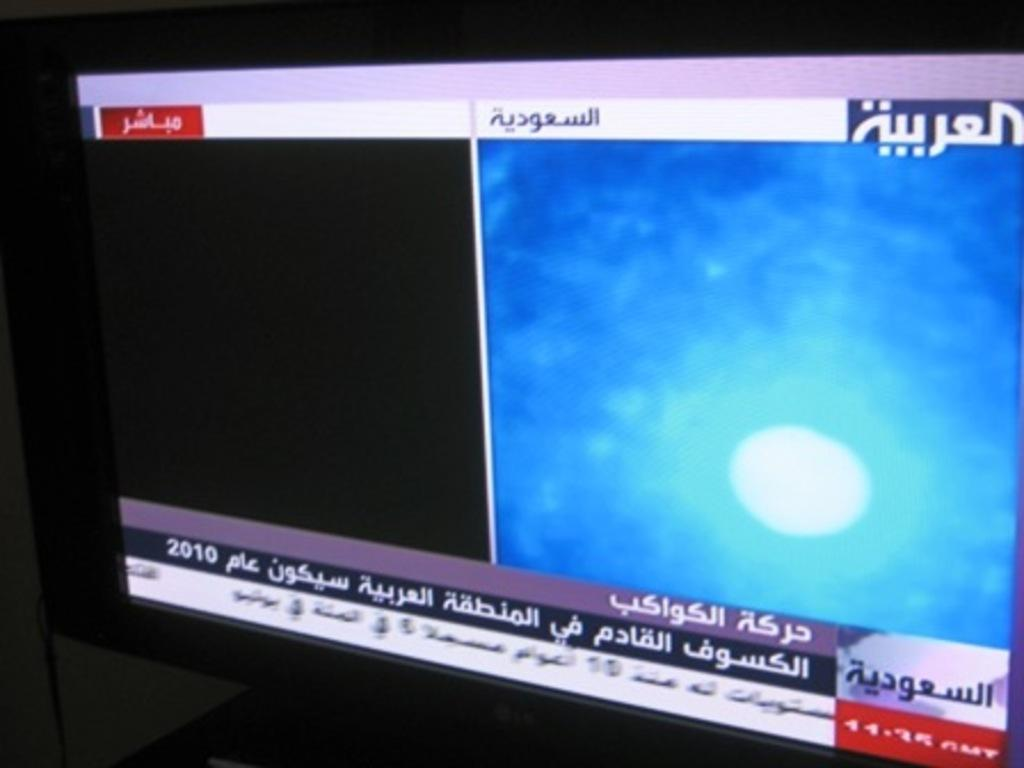Provide a one-sentence caption for the provided image. A television display shows the news in Arabic. 